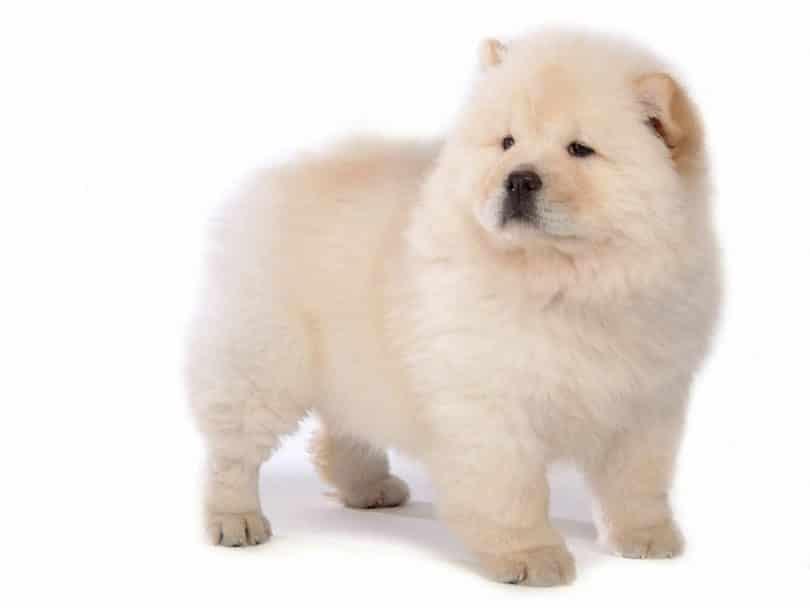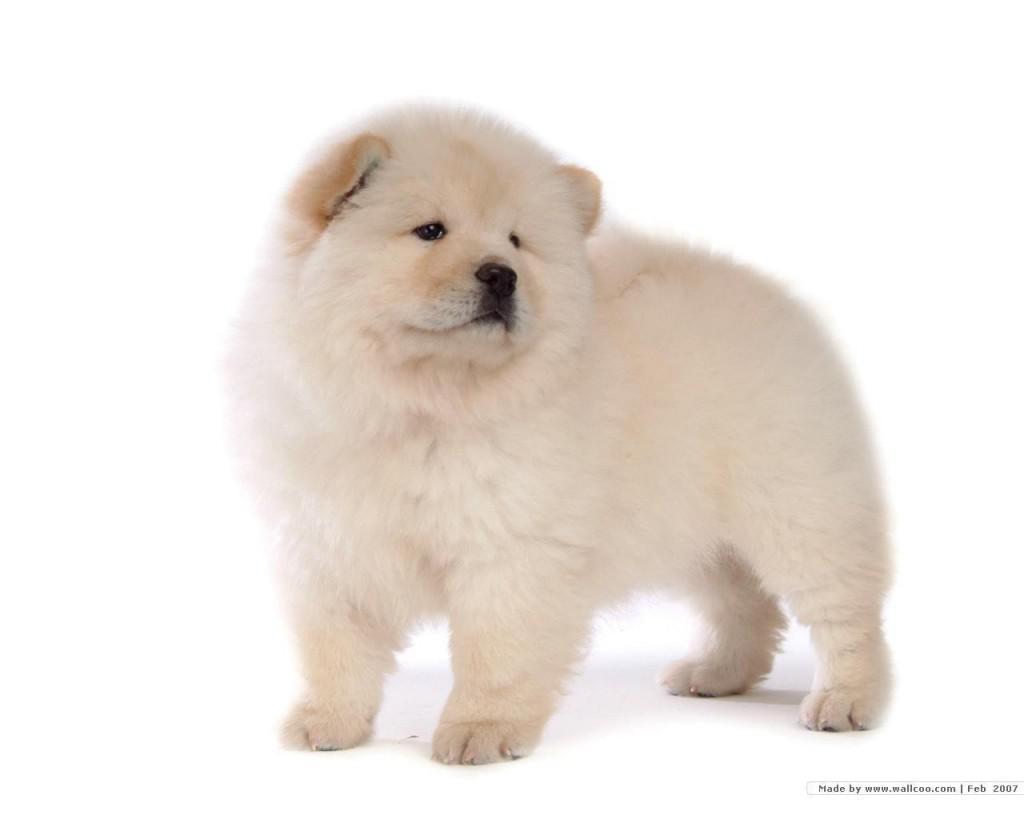The first image is the image on the left, the second image is the image on the right. Considering the images on both sides, is "The dogs in the two images look virtually identical." valid? Answer yes or no. Yes. 